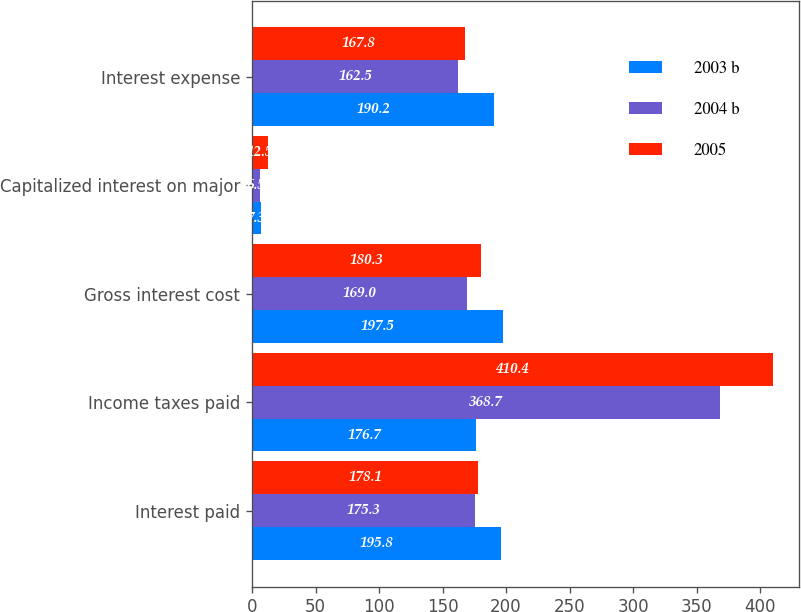Convert chart. <chart><loc_0><loc_0><loc_500><loc_500><stacked_bar_chart><ecel><fcel>Interest paid<fcel>Income taxes paid<fcel>Gross interest cost<fcel>Capitalized interest on major<fcel>Interest expense<nl><fcel>2003 b<fcel>195.8<fcel>176.7<fcel>197.5<fcel>7.3<fcel>190.2<nl><fcel>2004 b<fcel>175.3<fcel>368.7<fcel>169<fcel>6.5<fcel>162.5<nl><fcel>2005<fcel>178.1<fcel>410.4<fcel>180.3<fcel>12.5<fcel>167.8<nl></chart> 